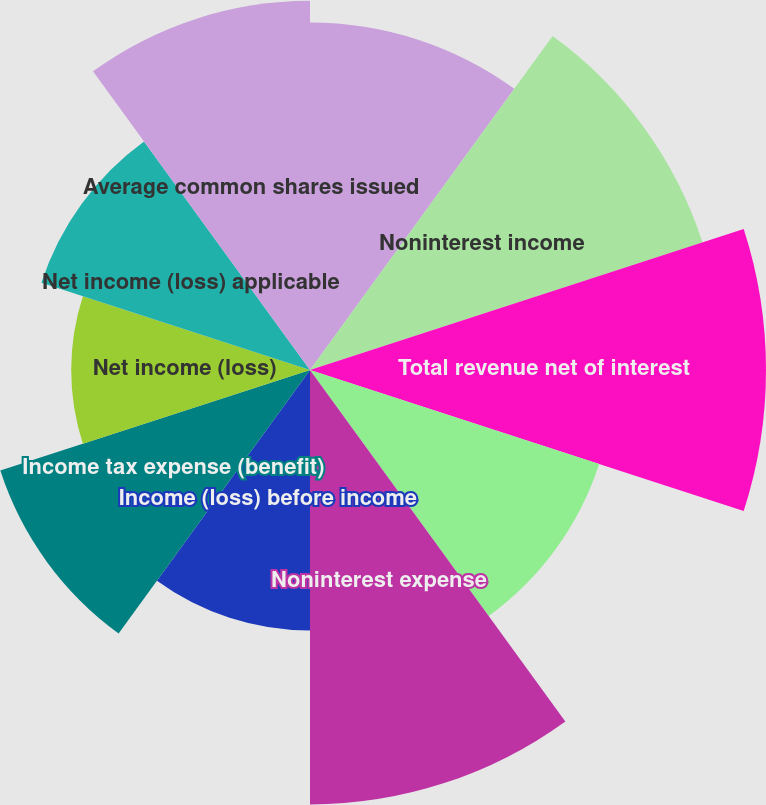Convert chart to OTSL. <chart><loc_0><loc_0><loc_500><loc_500><pie_chart><fcel>Net interest income<fcel>Noninterest income<fcel>Total revenue net of interest<fcel>Provision for credit losses<fcel>Noninterest expense<fcel>Income (loss) before income<fcel>Income tax expense (benefit)<fcel>Net income (loss)<fcel>Net income (loss) applicable<fcel>Average common shares issued<nl><fcel>10.13%<fcel>12.03%<fcel>13.29%<fcel>8.86%<fcel>12.66%<fcel>7.59%<fcel>9.49%<fcel>6.96%<fcel>8.23%<fcel>10.76%<nl></chart> 